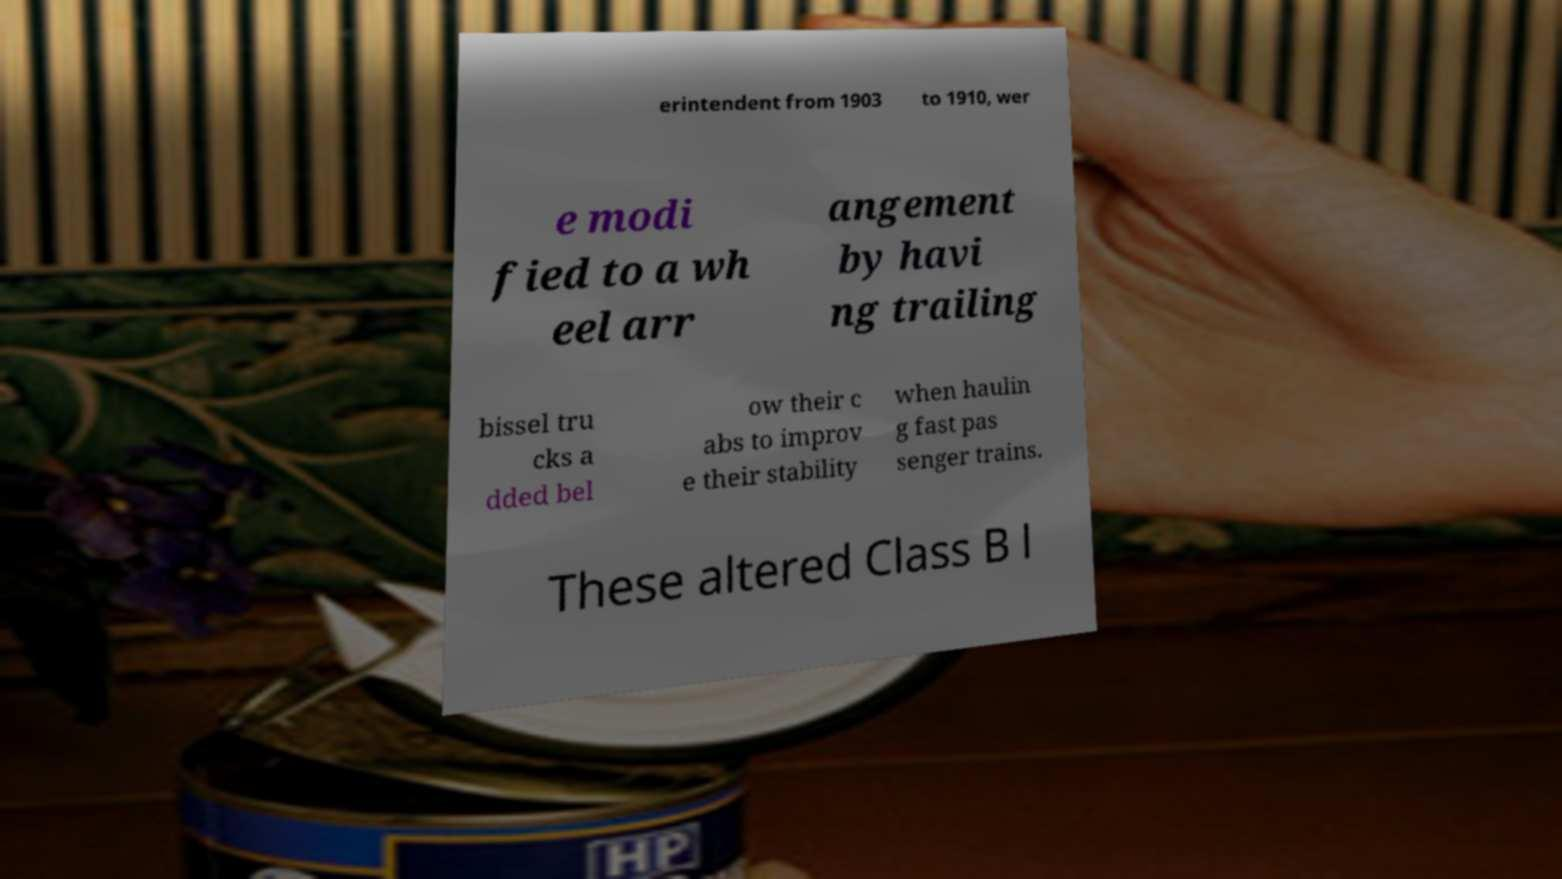I need the written content from this picture converted into text. Can you do that? erintendent from 1903 to 1910, wer e modi fied to a wh eel arr angement by havi ng trailing bissel tru cks a dded bel ow their c abs to improv e their stability when haulin g fast pas senger trains. These altered Class B l 